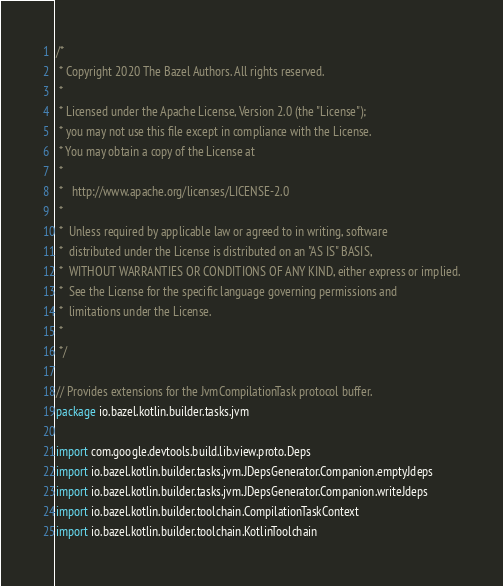<code> <loc_0><loc_0><loc_500><loc_500><_Kotlin_>/*
 * Copyright 2020 The Bazel Authors. All rights reserved.
 *
 * Licensed under the Apache License, Version 2.0 (the "License");
 * you may not use this file except in compliance with the License.
 * You may obtain a copy of the License at
 *
 *   http://www.apache.org/licenses/LICENSE-2.0
 *
 *  Unless required by applicable law or agreed to in writing, software
 *  distributed under the License is distributed on an "AS IS" BASIS,
 *  WITHOUT WARRANTIES OR CONDITIONS OF ANY KIND, either express or implied.
 *  See the License for the specific language governing permissions and
 *  limitations under the License.
 *
 */

// Provides extensions for the JvmCompilationTask protocol buffer.
package io.bazel.kotlin.builder.tasks.jvm

import com.google.devtools.build.lib.view.proto.Deps
import io.bazel.kotlin.builder.tasks.jvm.JDepsGenerator.Companion.emptyJdeps
import io.bazel.kotlin.builder.tasks.jvm.JDepsGenerator.Companion.writeJdeps
import io.bazel.kotlin.builder.toolchain.CompilationTaskContext
import io.bazel.kotlin.builder.toolchain.KotlinToolchain</code> 